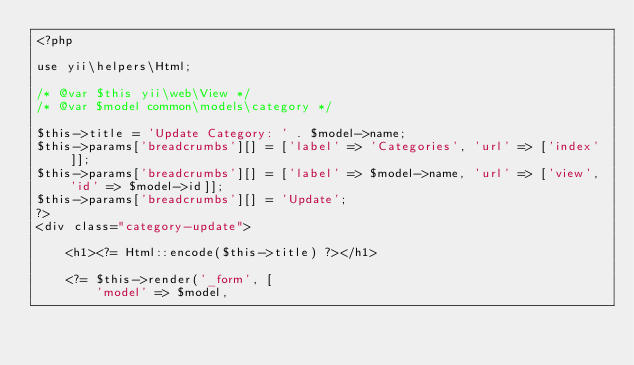<code> <loc_0><loc_0><loc_500><loc_500><_PHP_><?php

use yii\helpers\Html;

/* @var $this yii\web\View */
/* @var $model common\models\category */

$this->title = 'Update Category: ' . $model->name;
$this->params['breadcrumbs'][] = ['label' => 'Categories', 'url' => ['index']];
$this->params['breadcrumbs'][] = ['label' => $model->name, 'url' => ['view', 'id' => $model->id]];
$this->params['breadcrumbs'][] = 'Update';
?>
<div class="category-update">

    <h1><?= Html::encode($this->title) ?></h1>

    <?= $this->render('_form', [
        'model' => $model,</code> 